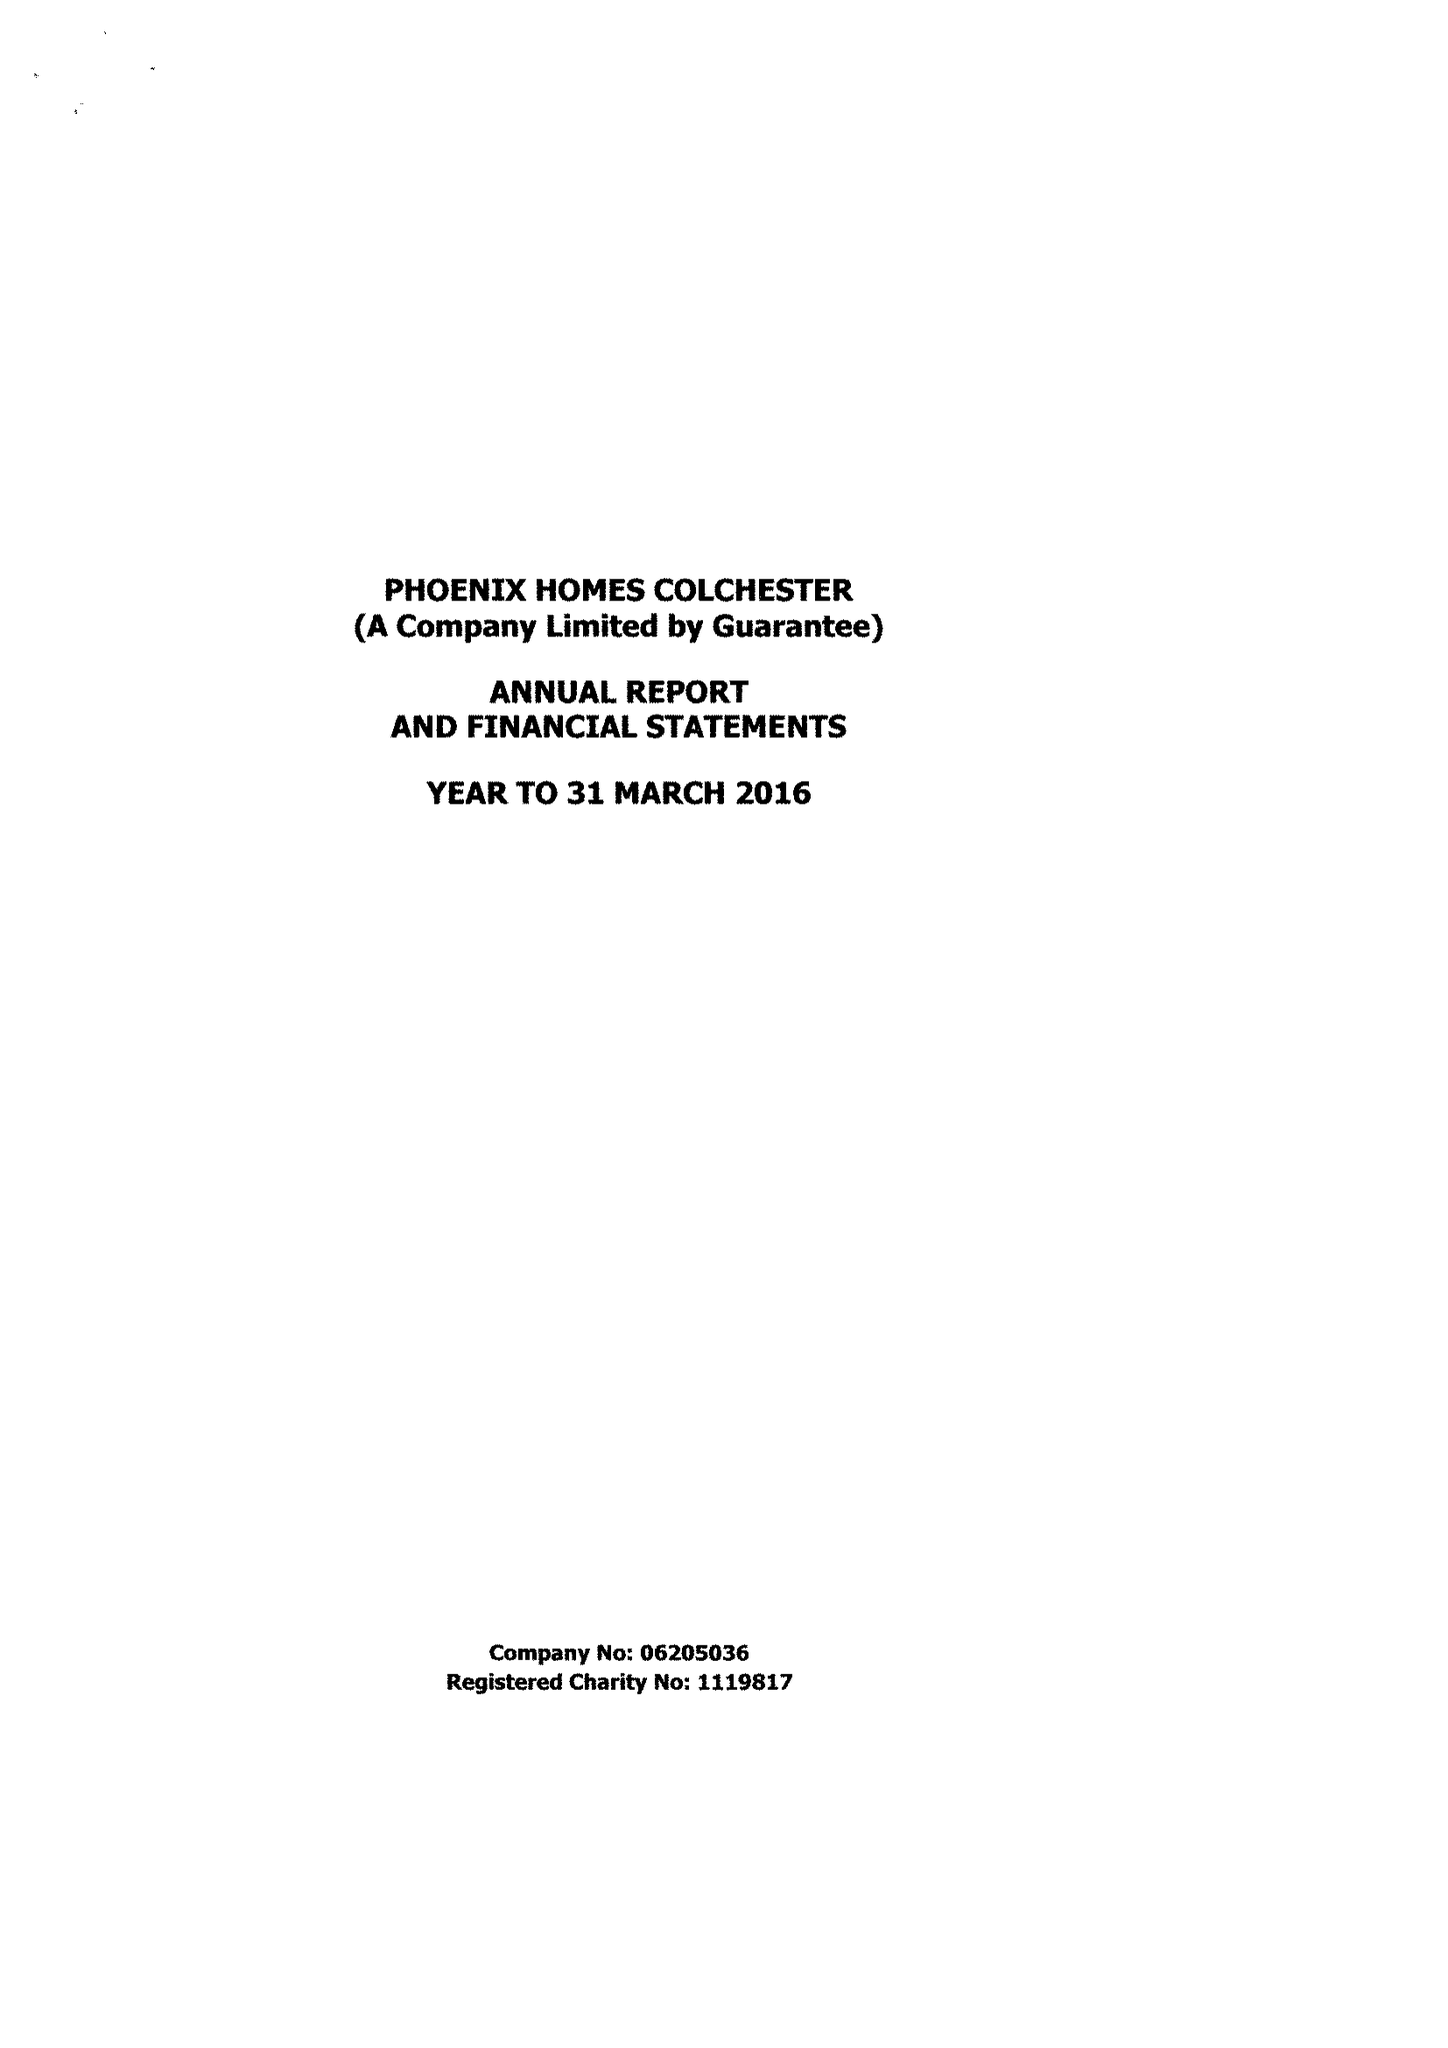What is the value for the address__post_town?
Answer the question using a single word or phrase. COLCHESTER 